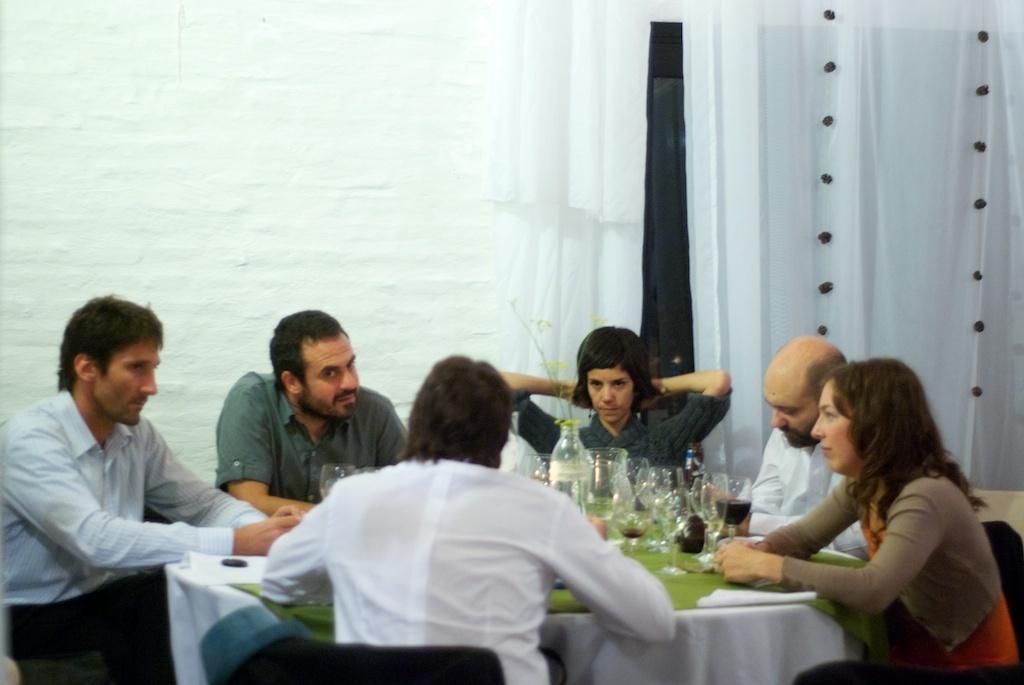Please provide a concise description of this image. In this picture there are people sitting on the chair around the table on which there are some items bottles and there is a white curtain. 